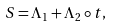Convert formula to latex. <formula><loc_0><loc_0><loc_500><loc_500>S = \Lambda _ { 1 } + \Lambda _ { 2 } \circ t ,</formula> 